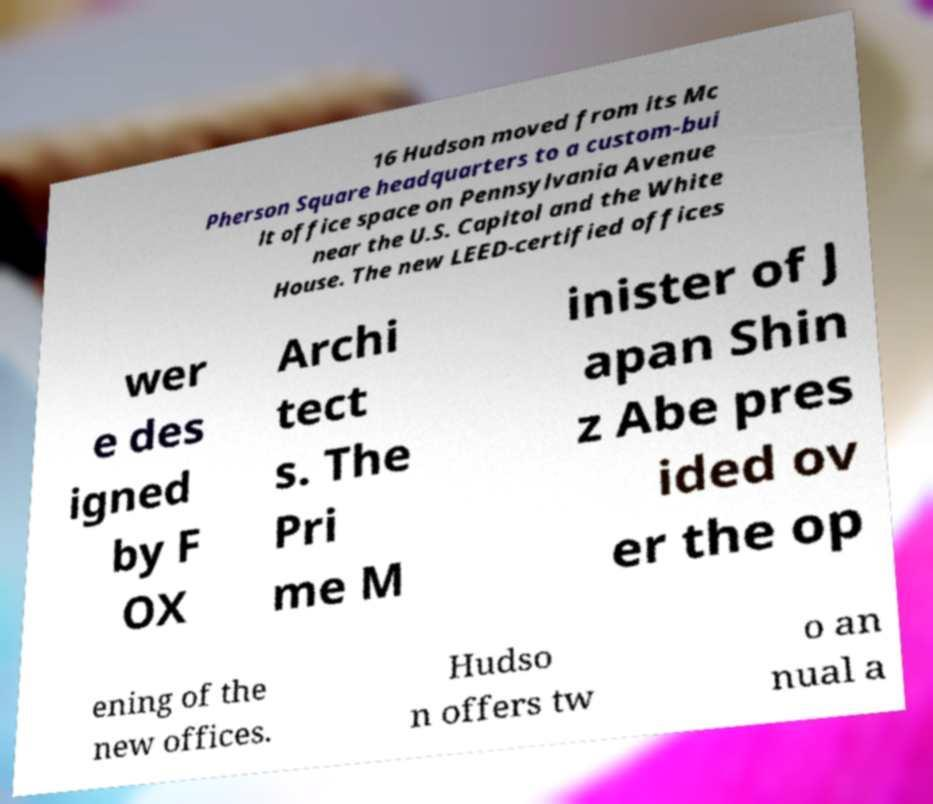Please identify and transcribe the text found in this image. 16 Hudson moved from its Mc Pherson Square headquarters to a custom-bui lt office space on Pennsylvania Avenue near the U.S. Capitol and the White House. The new LEED-certified offices wer e des igned by F OX Archi tect s. The Pri me M inister of J apan Shin z Abe pres ided ov er the op ening of the new offices. Hudso n offers tw o an nual a 